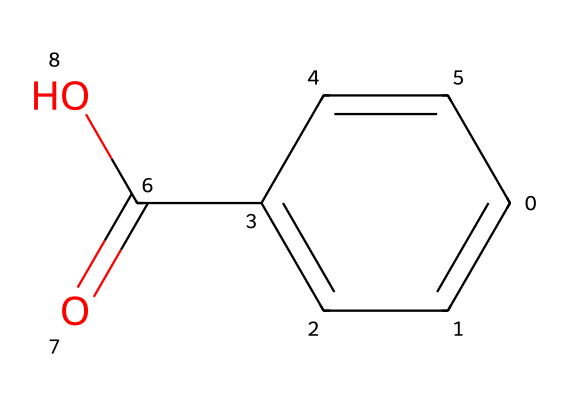What is the name of this chemical? The chemical structure corresponds to benzoic acid based on its unique carboxylic acid group (-COOH) attached to a benzene ring.
Answer: benzoic acid How many carbon atoms are in this structure? By analyzing the SMILES notation, we can count the distinct carbon atoms. The structure displays a benzene ring with additional carbons in the carboxylic group, totaling seven carbon atoms.
Answer: 7 What type of functional group is present in this chemical? The presence of the -COOH group indicates that this molecule contains a carboxylic acid functional group, which is characteristic of benzoic acid.
Answer: carboxylic acid How many hydrogen atoms are attached to the benzene ring? In the benzene ring, each carbon generally bonds with one hydrogen atom. Since one carbon is part of the carboxylic acid, the ring contributes five hydrogen atoms connected to the remaining five carbons.
Answer: 5 What is the primary use of this chemical? Benzoic acid is primarily used as a food preservative and can also serve as an antimicrobial agent in various applications, including printing inks.
Answer: preservative What type of bond connects the carbon atoms in the benzene ring? The carbon atoms within the benzene ring are connected by alternating double bonds, which create a resonance structure characterized by delocalized electrons.
Answer: double bonds Why is this chemical recognized as an effective preservative? The carboxylic acid functional group in benzoic acid disrupts microbial activity, making it effective at inhibiting the growth of bacteria and fungi, thereby acting as a preservative.
Answer: inhibits microbial growth 